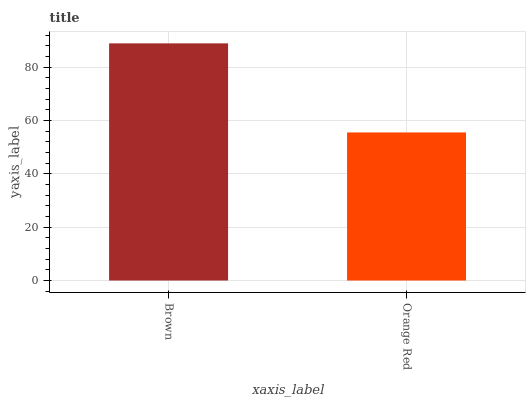Is Orange Red the maximum?
Answer yes or no. No. Is Brown greater than Orange Red?
Answer yes or no. Yes. Is Orange Red less than Brown?
Answer yes or no. Yes. Is Orange Red greater than Brown?
Answer yes or no. No. Is Brown less than Orange Red?
Answer yes or no. No. Is Brown the high median?
Answer yes or no. Yes. Is Orange Red the low median?
Answer yes or no. Yes. Is Orange Red the high median?
Answer yes or no. No. Is Brown the low median?
Answer yes or no. No. 